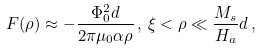<formula> <loc_0><loc_0><loc_500><loc_500>F ( \rho ) \approx - \frac { \Phi _ { 0 } ^ { 2 } d } { 2 \pi \mu _ { 0 } \alpha \rho } \, , \, \xi < \rho \ll \frac { M _ { s } } { H _ { a } } d \, ,</formula> 